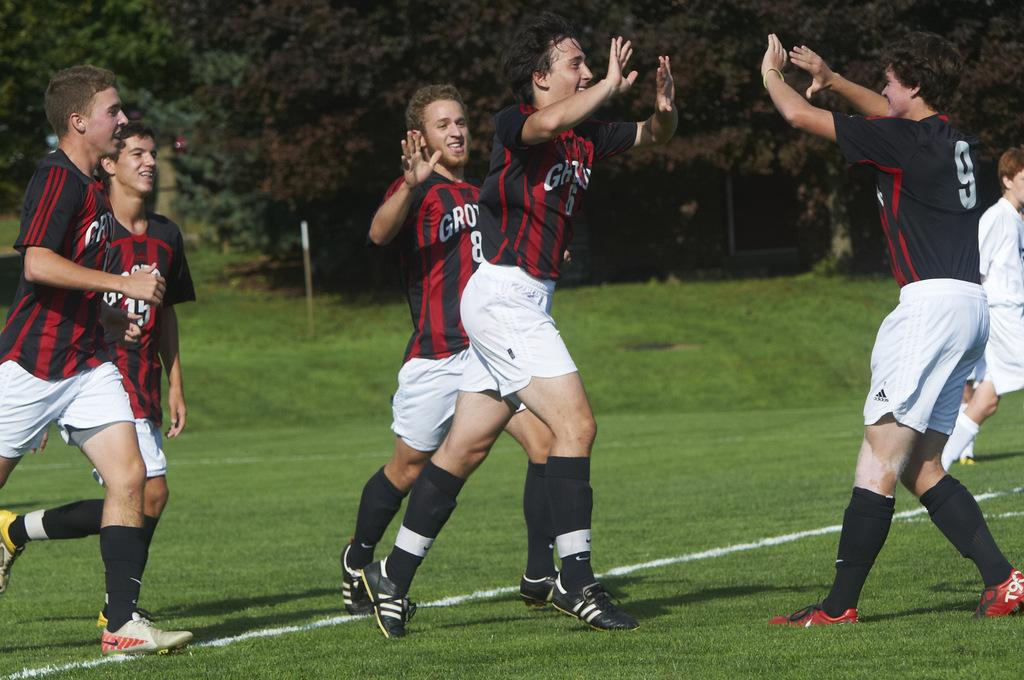What is the main subject of the image? The main subject of the image is the boys in the center. What are the boys doing in the image? The boys are walking. What type of terrain is visible at the bottom of the image? There is grass at the bottom of the image. What can be seen in the background of the image? There are trees and poles in the background of the image. How does the rake help the boys in the image? There is no rake present in the image, so it cannot help the boys. 